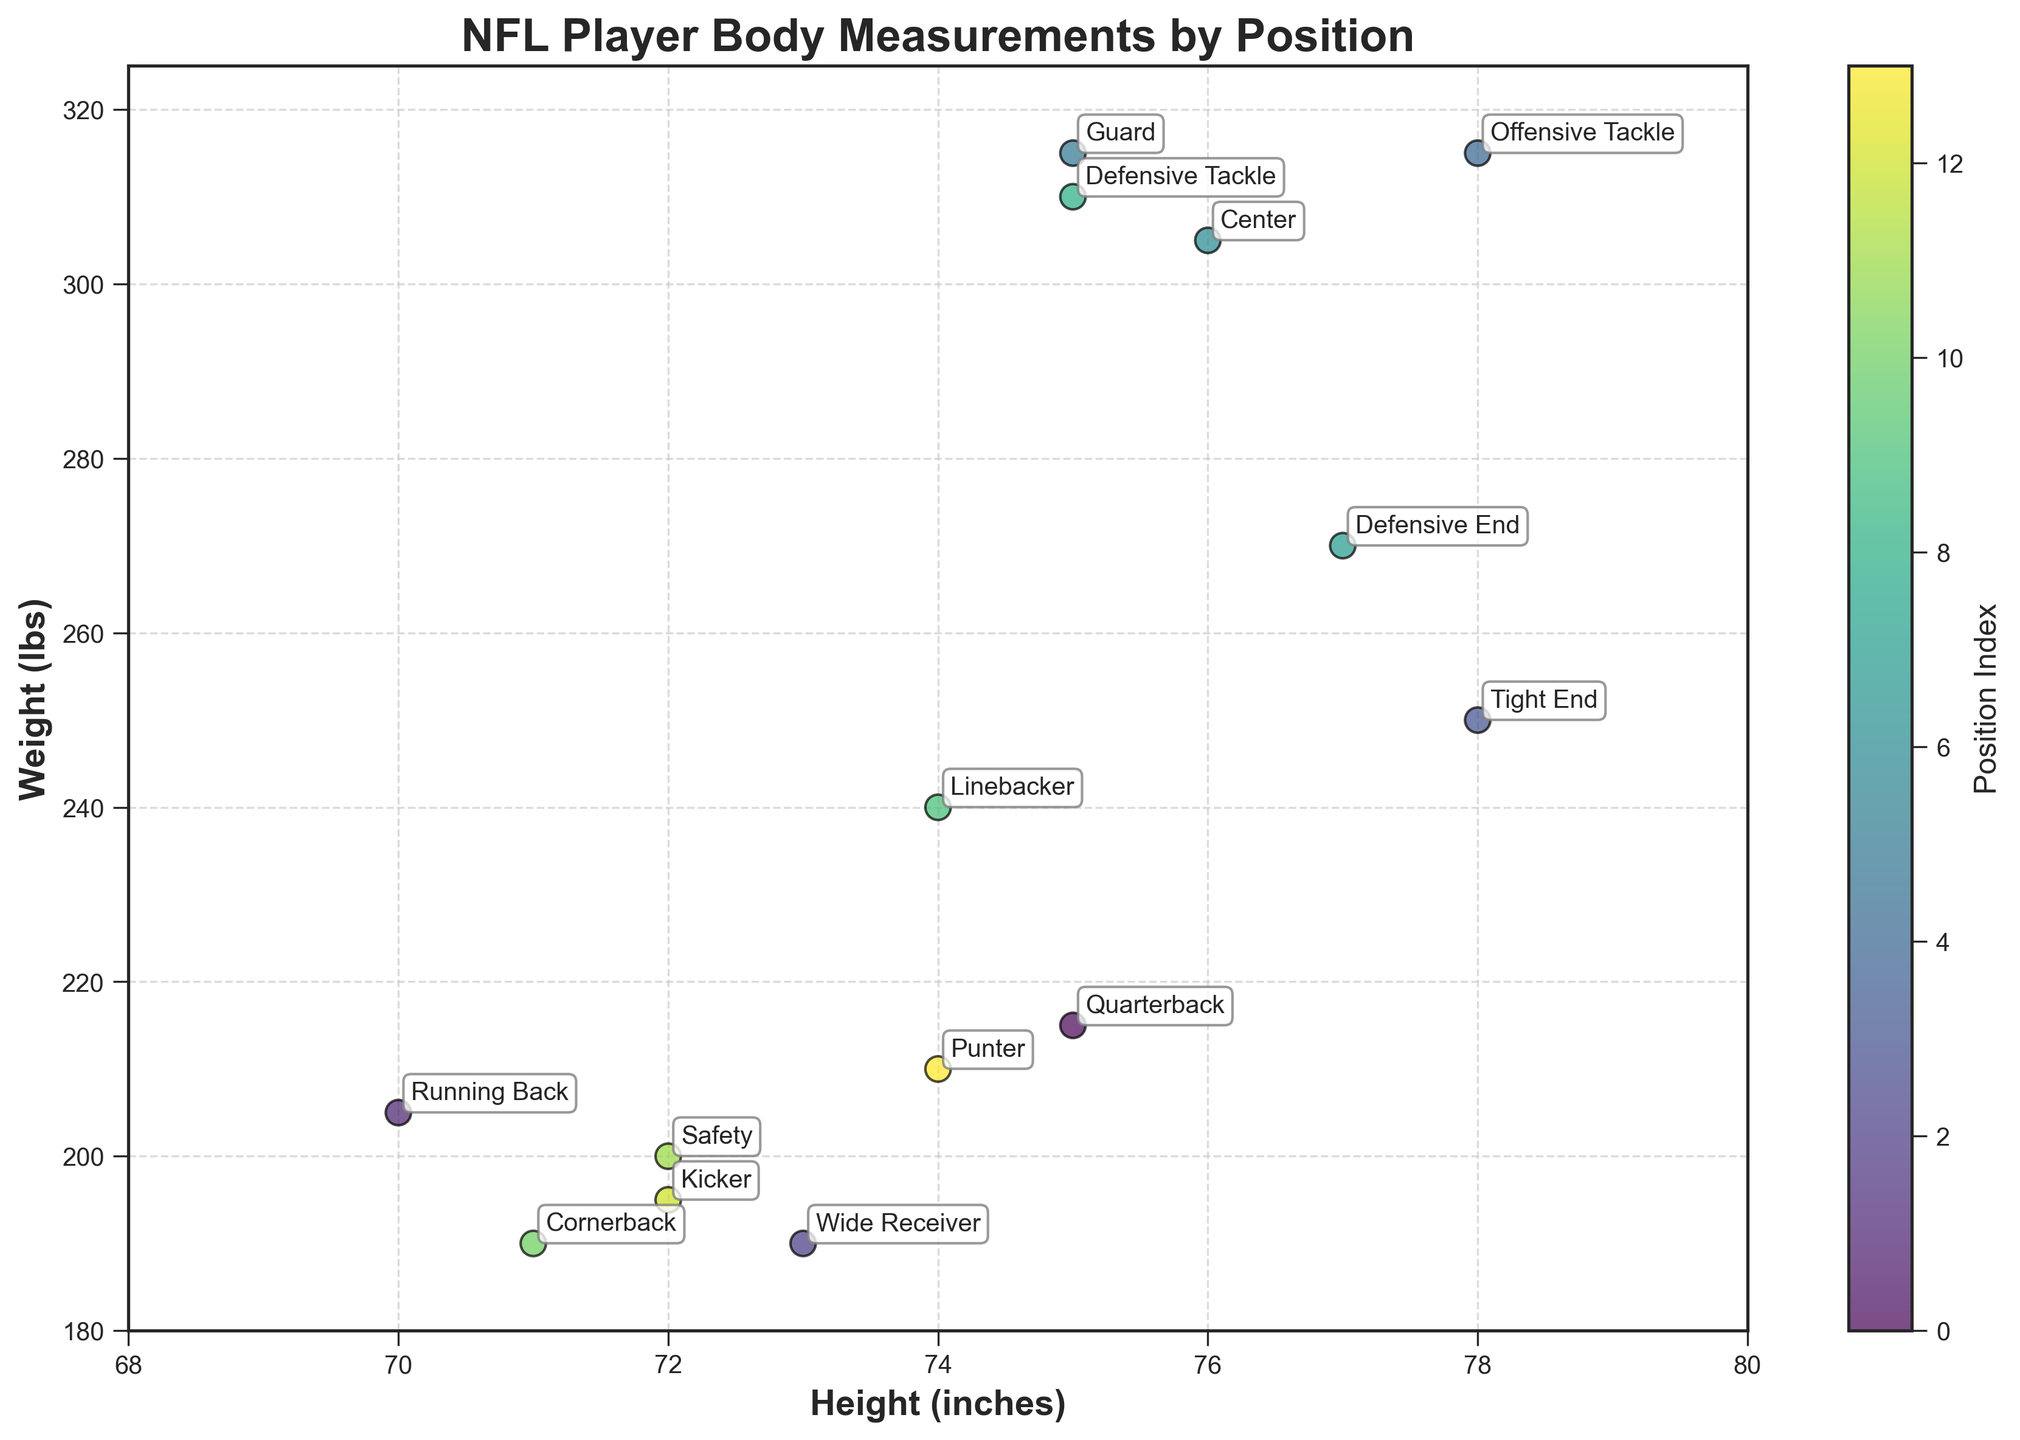What is the title of the plot? The title is located at the top of the figure and describes what the plot is about.
Answer: NFL Player Body Measurements by Position Which position has the highest weight for a given height? Observing the plotted points, the Offensive Tackle and Guard have the highest weight (315 lbs) for the same height (78 inches).
Answer: Offensive Tackle, Guard Which position has the greatest height that isn't the heaviest? From the height axis and observing the plot, the Tight End is the tallest non-heaviest position (78 inches but weighs 250 lbs).
Answer: Tight End What is the relationship between height and weight for the Defensive positions? Comparing the points labeled as Defensive End, Defensive Tackle, and Linebacker, we see that as the height remains roughly constant (74-77 inches), the weight varies from 240 lbs to 310 lbs.
Answer: Generally, weight increases with height in defensive positions, but there are variations How do the Special Teams (Kicker and Punter) compare in height and weight? Comparing the points labeled Kicker and Punter, we see that Kicker is 72 inches and 195 lbs, while Punter is 74 inches and 210 lbs.
Answer: Special teams players are quite similar, with the Punter being slightly taller and heavier 